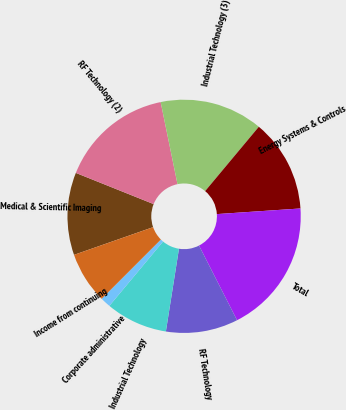Convert chart. <chart><loc_0><loc_0><loc_500><loc_500><pie_chart><fcel>Medical & Scientific Imaging<fcel>RF Technology (2)<fcel>Industrial Technology (3)<fcel>Energy Systems & Controls<fcel>Total<fcel>RF Technology<fcel>Industrial Technology<fcel>Corporate administrative<fcel>Income from continuing<nl><fcel>11.43%<fcel>15.71%<fcel>14.29%<fcel>12.86%<fcel>18.57%<fcel>10.0%<fcel>8.57%<fcel>1.43%<fcel>7.14%<nl></chart> 